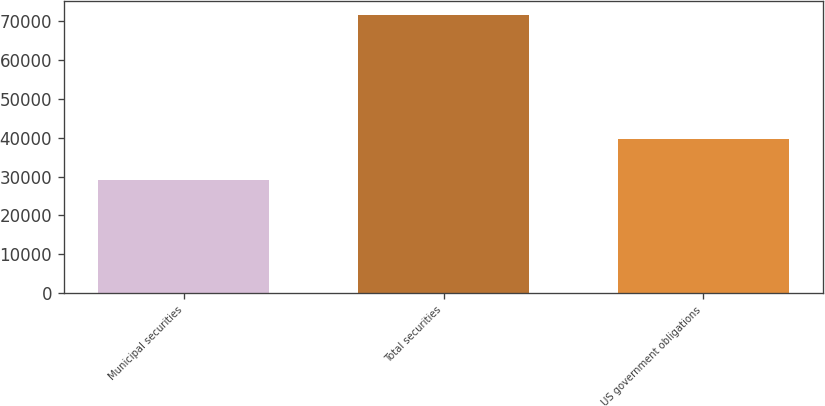Convert chart to OTSL. <chart><loc_0><loc_0><loc_500><loc_500><bar_chart><fcel>Municipal securities<fcel>Total securities<fcel>US government obligations<nl><fcel>29150<fcel>71589<fcel>39629<nl></chart> 